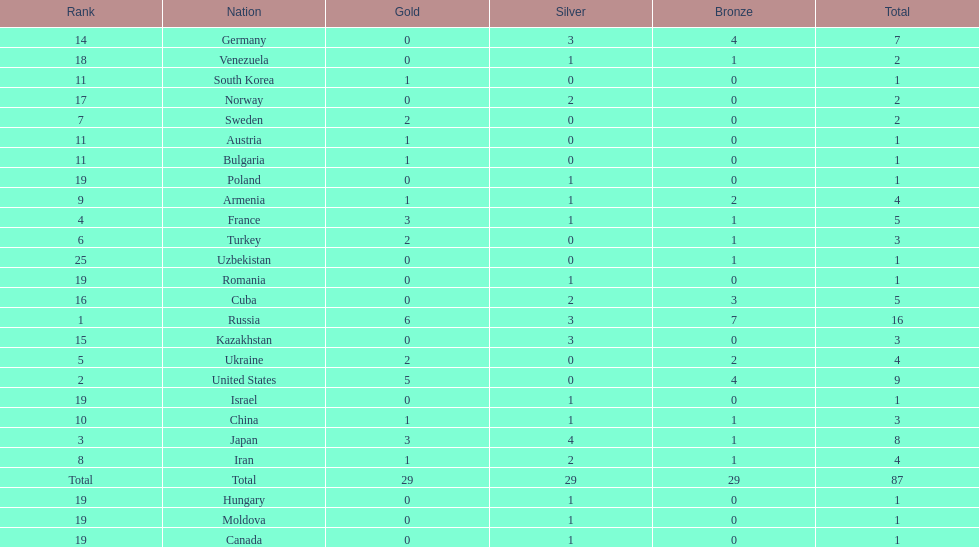Which nations participated in the championships? Russia, United States, Japan, France, Ukraine, Turkey, Sweden, Iran, Armenia, China, Austria, Bulgaria, South Korea, Germany, Kazakhstan, Cuba, Norway, Venezuela, Canada, Hungary, Israel, Moldova, Poland, Romania, Uzbekistan. How many bronze medals did they receive? 7, 4, 1, 1, 2, 1, 0, 1, 2, 1, 0, 0, 0, 4, 0, 3, 0, 1, 0, 0, 0, 0, 0, 0, 1, 29. Give me the full table as a dictionary. {'header': ['Rank', 'Nation', 'Gold', 'Silver', 'Bronze', 'Total'], 'rows': [['14', 'Germany', '0', '3', '4', '7'], ['18', 'Venezuela', '0', '1', '1', '2'], ['11', 'South Korea', '1', '0', '0', '1'], ['17', 'Norway', '0', '2', '0', '2'], ['7', 'Sweden', '2', '0', '0', '2'], ['11', 'Austria', '1', '0', '0', '1'], ['11', 'Bulgaria', '1', '0', '0', '1'], ['19', 'Poland', '0', '1', '0', '1'], ['9', 'Armenia', '1', '1', '2', '4'], ['4', 'France', '3', '1', '1', '5'], ['6', 'Turkey', '2', '0', '1', '3'], ['25', 'Uzbekistan', '0', '0', '1', '1'], ['19', 'Romania', '0', '1', '0', '1'], ['16', 'Cuba', '0', '2', '3', '5'], ['1', 'Russia', '6', '3', '7', '16'], ['15', 'Kazakhstan', '0', '3', '0', '3'], ['5', 'Ukraine', '2', '0', '2', '4'], ['2', 'United States', '5', '0', '4', '9'], ['19', 'Israel', '0', '1', '0', '1'], ['10', 'China', '1', '1', '1', '3'], ['3', 'Japan', '3', '4', '1', '8'], ['8', 'Iran', '1', '2', '1', '4'], ['Total', 'Total', '29', '29', '29', '87'], ['19', 'Hungary', '0', '1', '0', '1'], ['19', 'Moldova', '0', '1', '0', '1'], ['19', 'Canada', '0', '1', '0', '1']]} How many in total? 16, 9, 8, 5, 4, 3, 2, 4, 4, 3, 1, 1, 1, 7, 3, 5, 2, 2, 1, 1, 1, 1, 1, 1, 1. And which team won only one medal -- the bronze? Uzbekistan. 